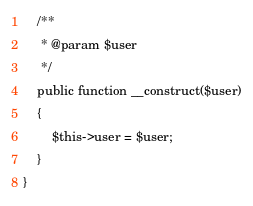Convert code to text. <code><loc_0><loc_0><loc_500><loc_500><_PHP_>
	/**
	 * @param $user
	 */
	public function __construct($user)
	{
		$this->user = $user;
	}
}</code> 